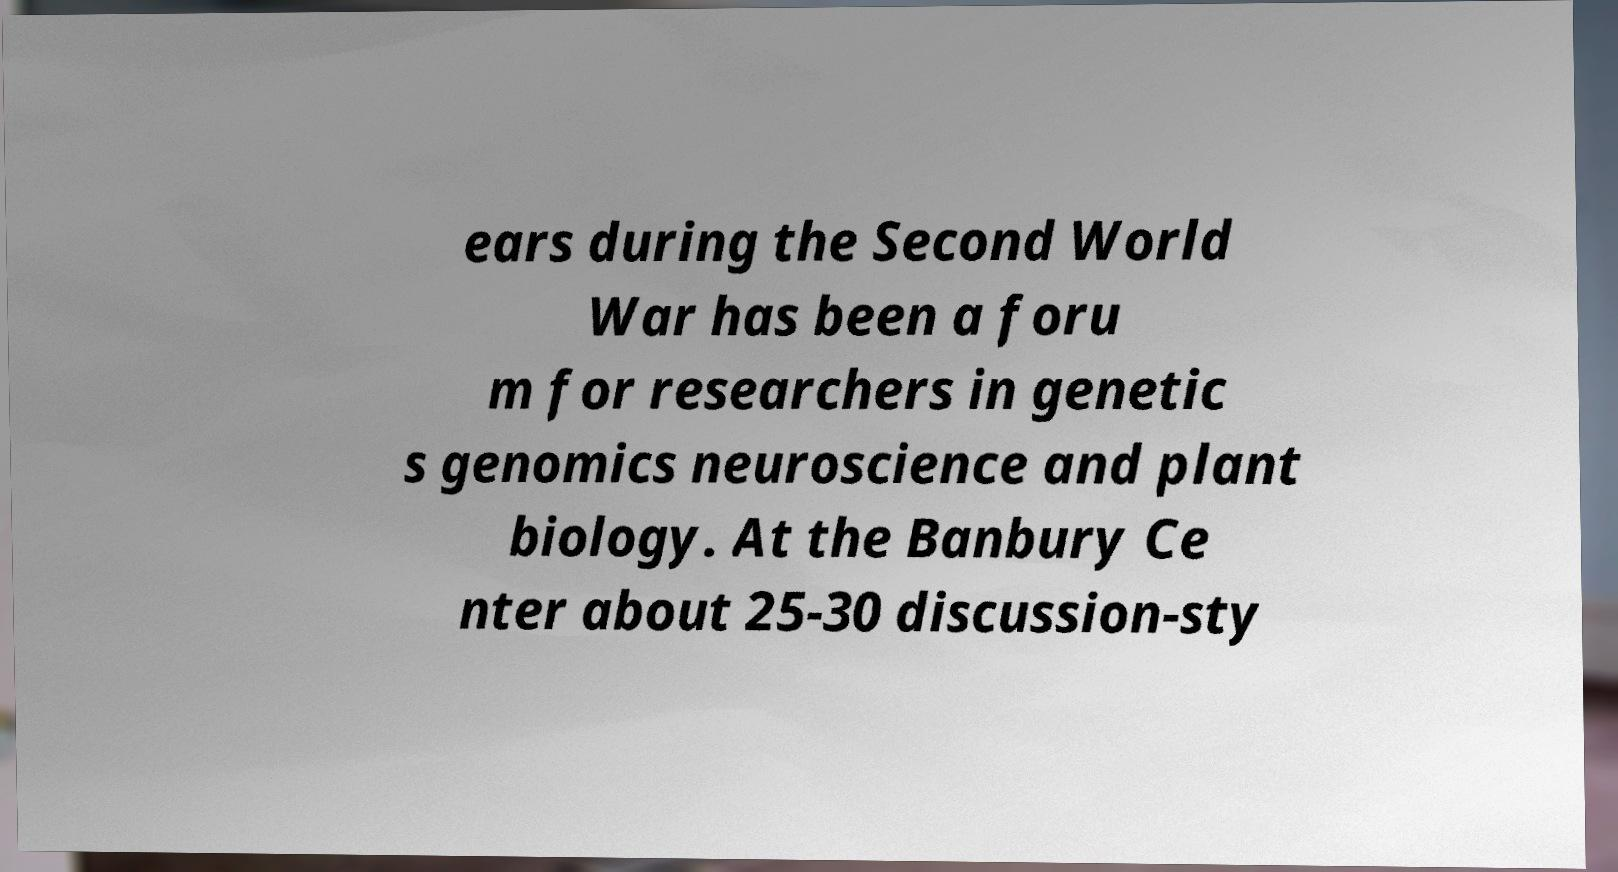Please identify and transcribe the text found in this image. ears during the Second World War has been a foru m for researchers in genetic s genomics neuroscience and plant biology. At the Banbury Ce nter about 25-30 discussion-sty 